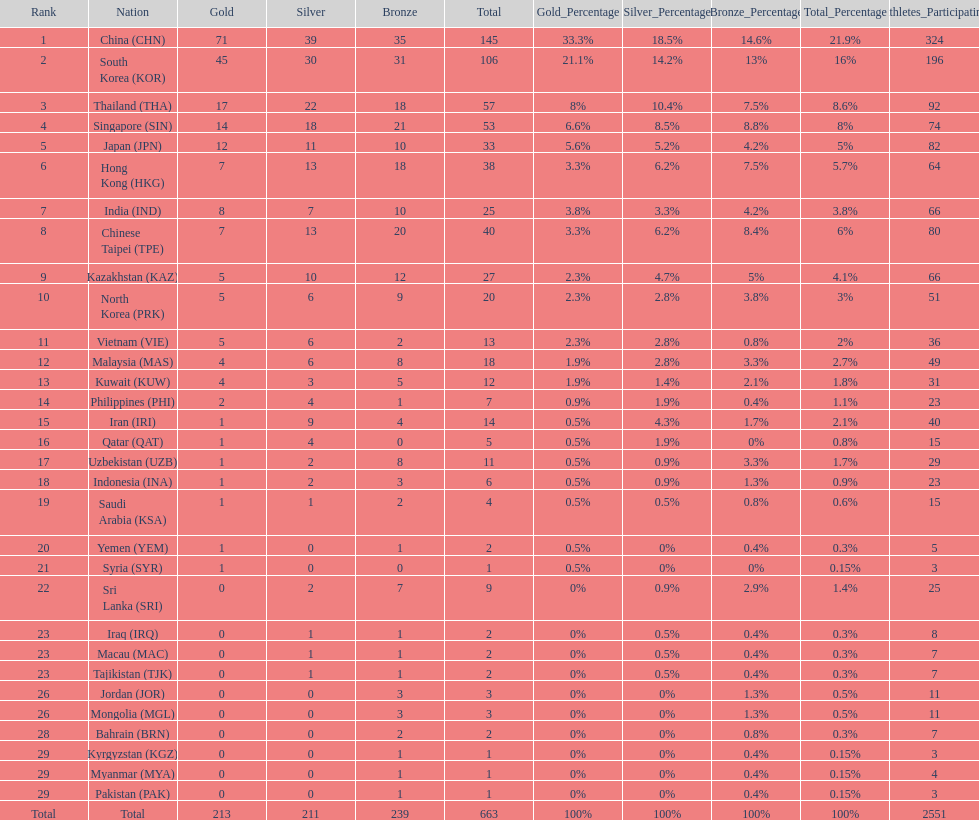Which nation has more gold medals, kuwait or india? India (IND). 